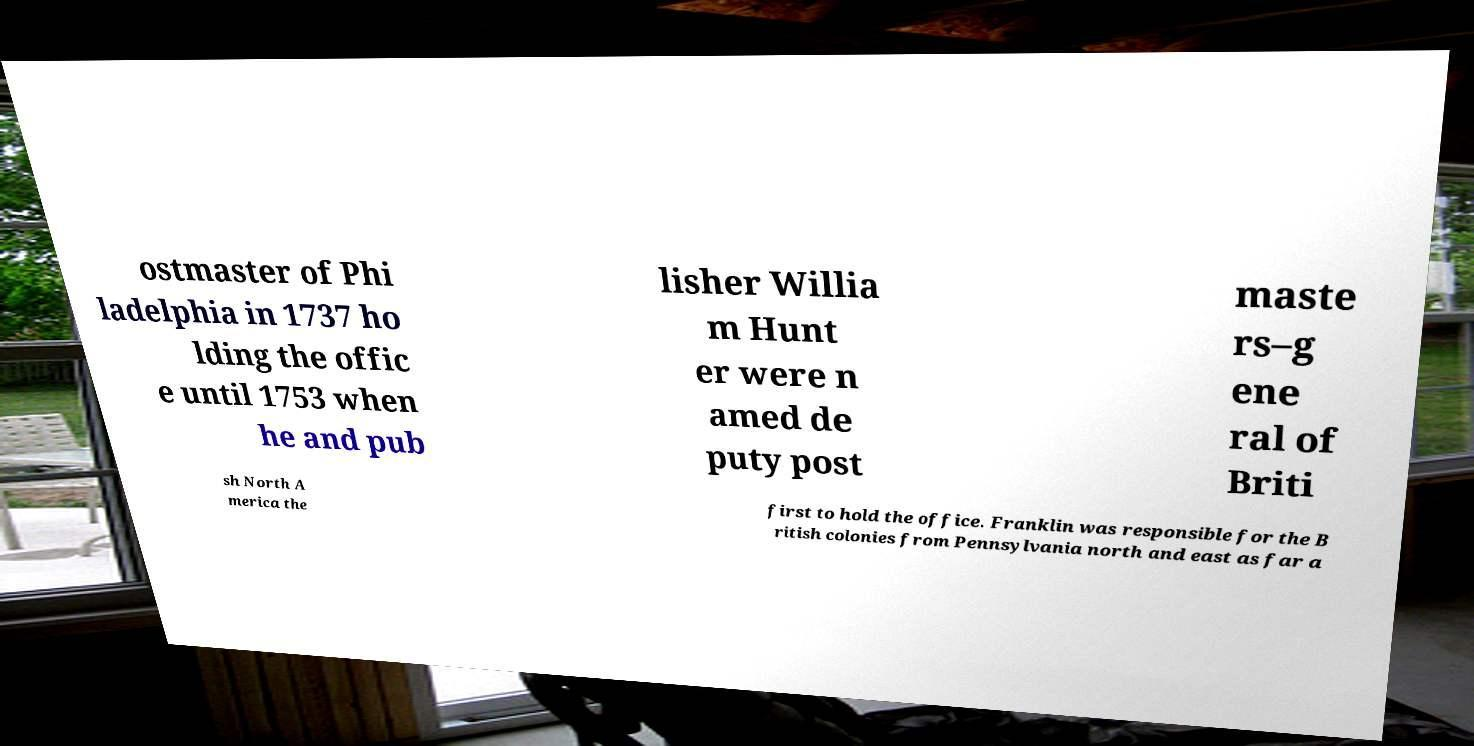I need the written content from this picture converted into text. Can you do that? ostmaster of Phi ladelphia in 1737 ho lding the offic e until 1753 when he and pub lisher Willia m Hunt er were n amed de puty post maste rs–g ene ral of Briti sh North A merica the first to hold the office. Franklin was responsible for the B ritish colonies from Pennsylvania north and east as far a 